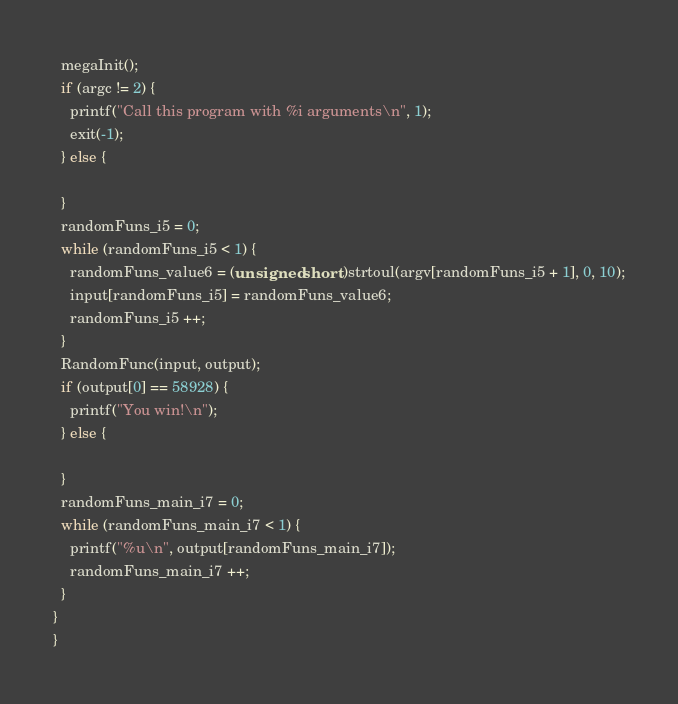Convert code to text. <code><loc_0><loc_0><loc_500><loc_500><_C_>  megaInit();
  if (argc != 2) {
    printf("Call this program with %i arguments\n", 1);
    exit(-1);
  } else {

  }
  randomFuns_i5 = 0;
  while (randomFuns_i5 < 1) {
    randomFuns_value6 = (unsigned short )strtoul(argv[randomFuns_i5 + 1], 0, 10);
    input[randomFuns_i5] = randomFuns_value6;
    randomFuns_i5 ++;
  }
  RandomFunc(input, output);
  if (output[0] == 58928) {
    printf("You win!\n");
  } else {

  }
  randomFuns_main_i7 = 0;
  while (randomFuns_main_i7 < 1) {
    printf("%u\n", output[randomFuns_main_i7]);
    randomFuns_main_i7 ++;
  }
}
}
</code> 